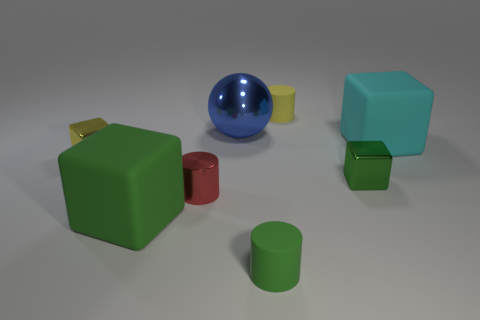Subtract all small green rubber cylinders. How many cylinders are left? 2 Subtract all red cylinders. How many cylinders are left? 2 Subtract all balls. How many objects are left? 7 Add 2 metal blocks. How many objects exist? 10 Add 2 cyan cylinders. How many cyan cylinders exist? 2 Subtract 0 brown cylinders. How many objects are left? 8 Subtract 2 cubes. How many cubes are left? 2 Subtract all gray cylinders. Subtract all yellow blocks. How many cylinders are left? 3 Subtract all red cylinders. How many cyan cubes are left? 1 Subtract all large cyan blocks. Subtract all shiny objects. How many objects are left? 3 